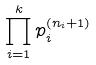Convert formula to latex. <formula><loc_0><loc_0><loc_500><loc_500>\prod _ { i = 1 } ^ { k } p _ { i } ^ { ( n _ { i } + 1 ) }</formula> 